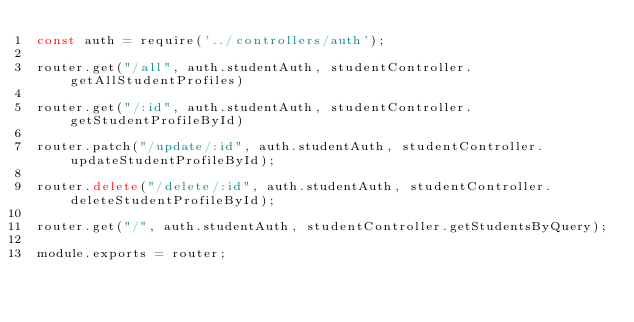Convert code to text. <code><loc_0><loc_0><loc_500><loc_500><_JavaScript_>const auth = require('../controllers/auth');

router.get("/all", auth.studentAuth, studentController.getAllStudentProfiles)

router.get("/:id", auth.studentAuth, studentController.getStudentProfileById)

router.patch("/update/:id", auth.studentAuth, studentController.updateStudentProfileById);

router.delete("/delete/:id", auth.studentAuth, studentController.deleteStudentProfileById);

router.get("/", auth.studentAuth, studentController.getStudentsByQuery);

module.exports = router;</code> 